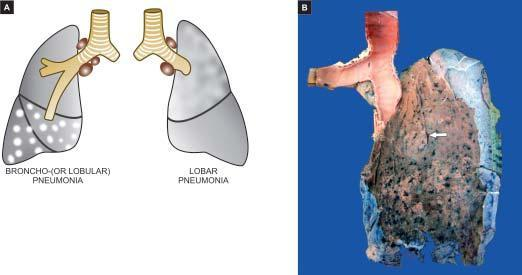does the pleural surface of the specimen of the lung show serofibrinous exudate?
Answer the question using a single word or phrase. Yes 